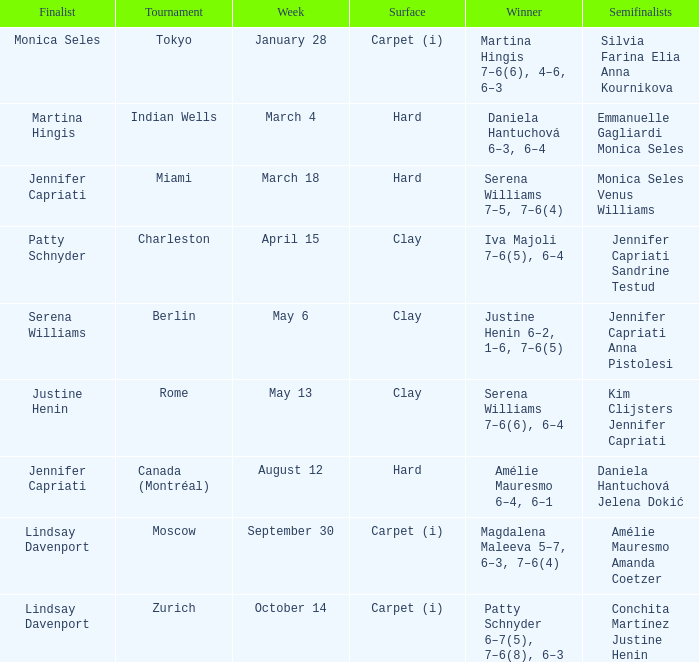What was the surface for finalist Justine Henin? Clay. Could you help me parse every detail presented in this table? {'header': ['Finalist', 'Tournament', 'Week', 'Surface', 'Winner', 'Semifinalists'], 'rows': [['Monica Seles', 'Tokyo', 'January 28', 'Carpet (i)', 'Martina Hingis 7–6(6), 4–6, 6–3', 'Silvia Farina Elia Anna Kournikova'], ['Martina Hingis', 'Indian Wells', 'March 4', 'Hard', 'Daniela Hantuchová 6–3, 6–4', 'Emmanuelle Gagliardi Monica Seles'], ['Jennifer Capriati', 'Miami', 'March 18', 'Hard', 'Serena Williams 7–5, 7–6(4)', 'Monica Seles Venus Williams'], ['Patty Schnyder', 'Charleston', 'April 15', 'Clay', 'Iva Majoli 7–6(5), 6–4', 'Jennifer Capriati Sandrine Testud'], ['Serena Williams', 'Berlin', 'May 6', 'Clay', 'Justine Henin 6–2, 1–6, 7–6(5)', 'Jennifer Capriati Anna Pistolesi'], ['Justine Henin', 'Rome', 'May 13', 'Clay', 'Serena Williams 7–6(6), 6–4', 'Kim Clijsters Jennifer Capriati'], ['Jennifer Capriati', 'Canada (Montréal)', 'August 12', 'Hard', 'Amélie Mauresmo 6–4, 6–1', 'Daniela Hantuchová Jelena Dokić'], ['Lindsay Davenport', 'Moscow', 'September 30', 'Carpet (i)', 'Magdalena Maleeva 5–7, 6–3, 7–6(4)', 'Amélie Mauresmo Amanda Coetzer'], ['Lindsay Davenport', 'Zurich', 'October 14', 'Carpet (i)', 'Patty Schnyder 6–7(5), 7–6(8), 6–3', 'Conchita Martínez Justine Henin']]} 